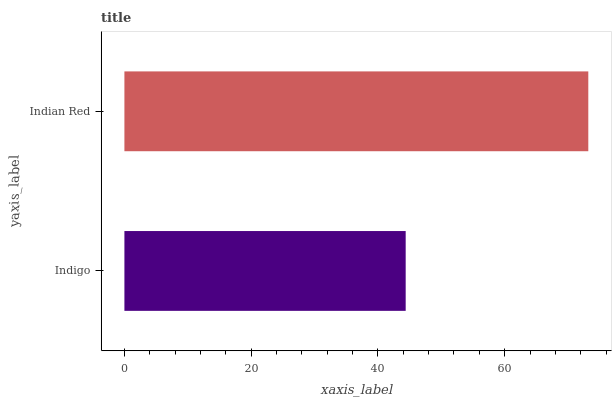Is Indigo the minimum?
Answer yes or no. Yes. Is Indian Red the maximum?
Answer yes or no. Yes. Is Indian Red the minimum?
Answer yes or no. No. Is Indian Red greater than Indigo?
Answer yes or no. Yes. Is Indigo less than Indian Red?
Answer yes or no. Yes. Is Indigo greater than Indian Red?
Answer yes or no. No. Is Indian Red less than Indigo?
Answer yes or no. No. Is Indian Red the high median?
Answer yes or no. Yes. Is Indigo the low median?
Answer yes or no. Yes. Is Indigo the high median?
Answer yes or no. No. Is Indian Red the low median?
Answer yes or no. No. 